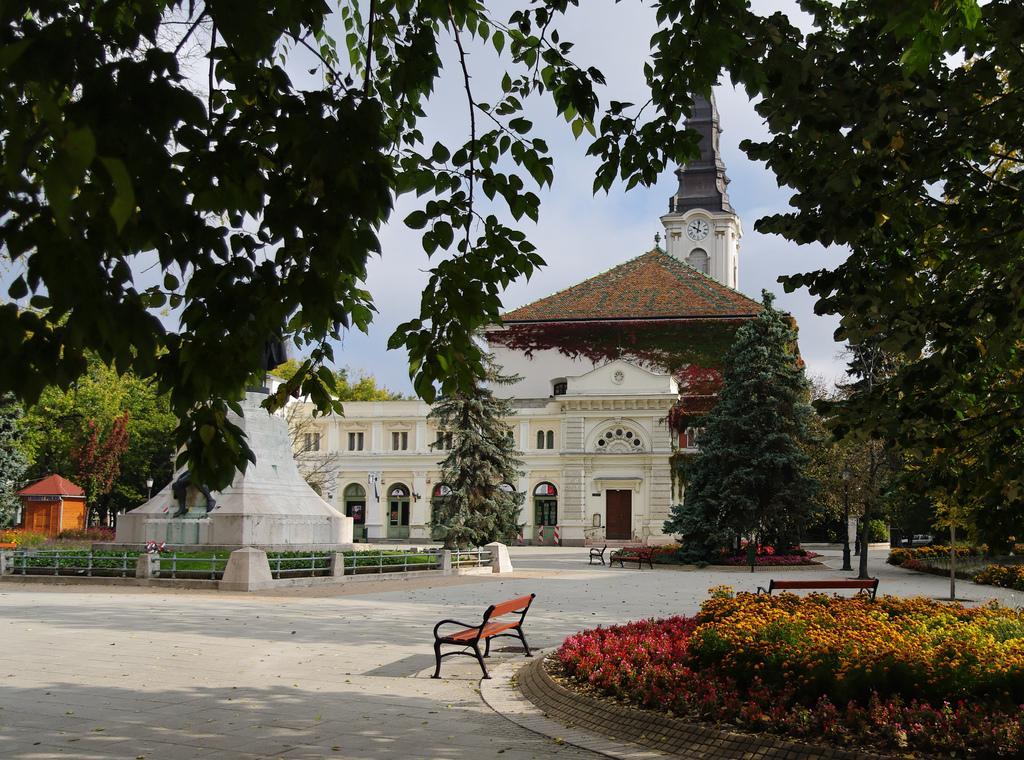Describe this image in one or two sentences. This picture is clicked outside. In the foreground we can see the flowers, plants, green grass and benches and we can see the trees. In the center we can see the buildings and a spire and we can see the clock attached to the wall of a spire and we can see the windows of the buildings and there is a white color object. On the left we can see a cabin. In the background we can see the sky, trees and many other objects. On the right corner we can see a vehicle. 